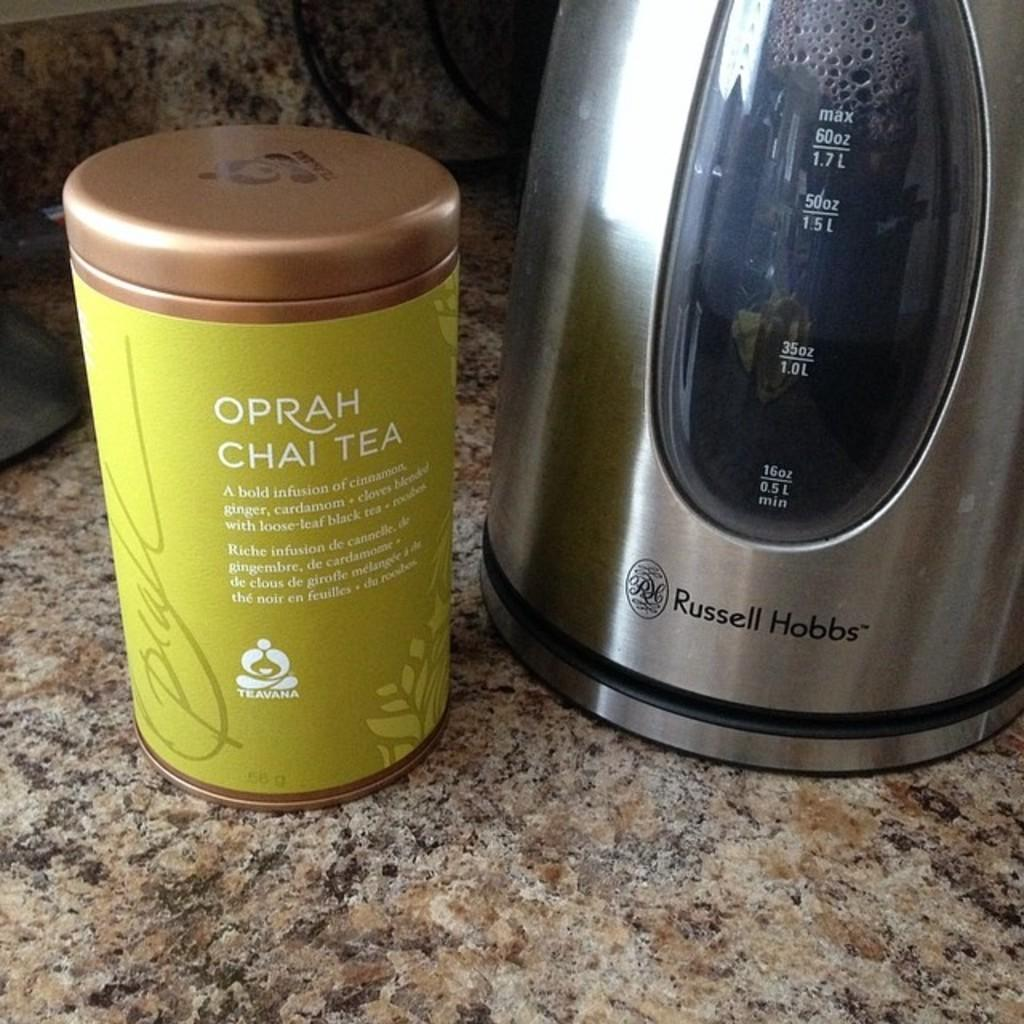<image>
Present a compact description of the photo's key features. a cup that has the word oprah on the front 